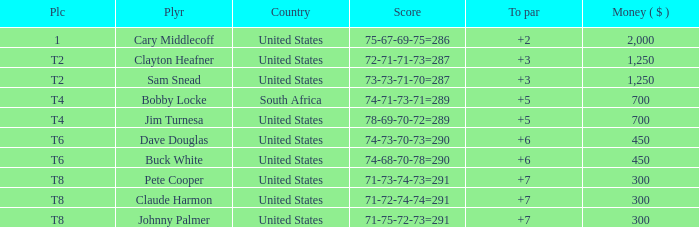What is Claude Harmon's Place? T8. 